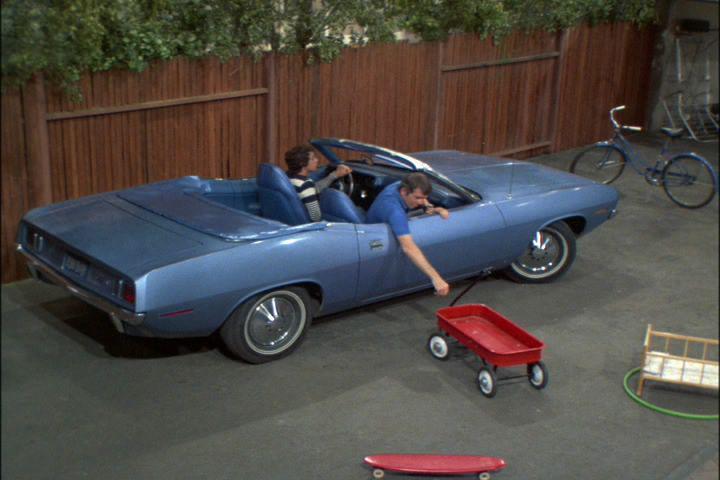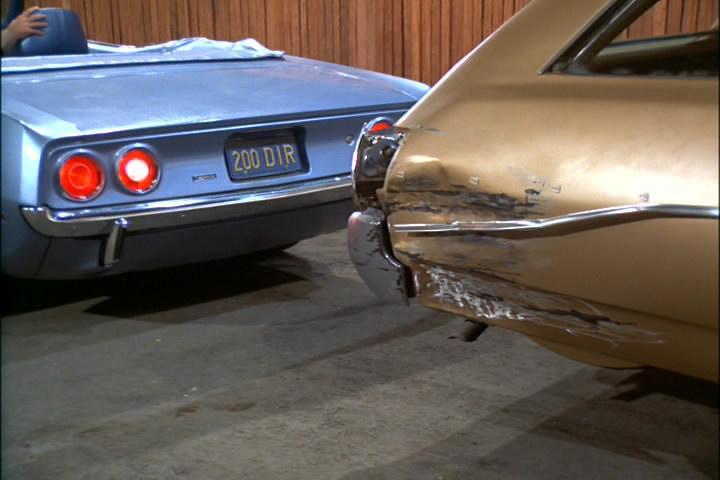The first image is the image on the left, the second image is the image on the right. Analyze the images presented: Is the assertion "An image shows a young male standing at the front of a beat-up looking convertible." valid? Answer yes or no. No. The first image is the image on the left, the second image is the image on the right. For the images displayed, is the sentence "A human is standing in front of a car in one photo." factually correct? Answer yes or no. No. 